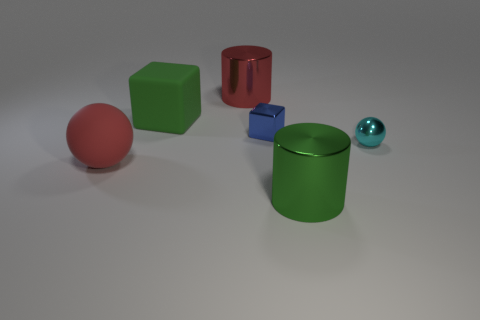Subtract all blocks. How many objects are left? 4 Add 3 tiny brown objects. How many objects exist? 9 Subtract all green cylinders. How many cylinders are left? 1 Subtract 1 cyan spheres. How many objects are left? 5 Subtract 2 cubes. How many cubes are left? 0 Subtract all yellow spheres. Subtract all purple blocks. How many spheres are left? 2 Subtract all yellow cylinders. How many green blocks are left? 1 Subtract all shiny things. Subtract all blue things. How many objects are left? 1 Add 3 green cubes. How many green cubes are left? 4 Add 6 big red rubber objects. How many big red rubber objects exist? 7 